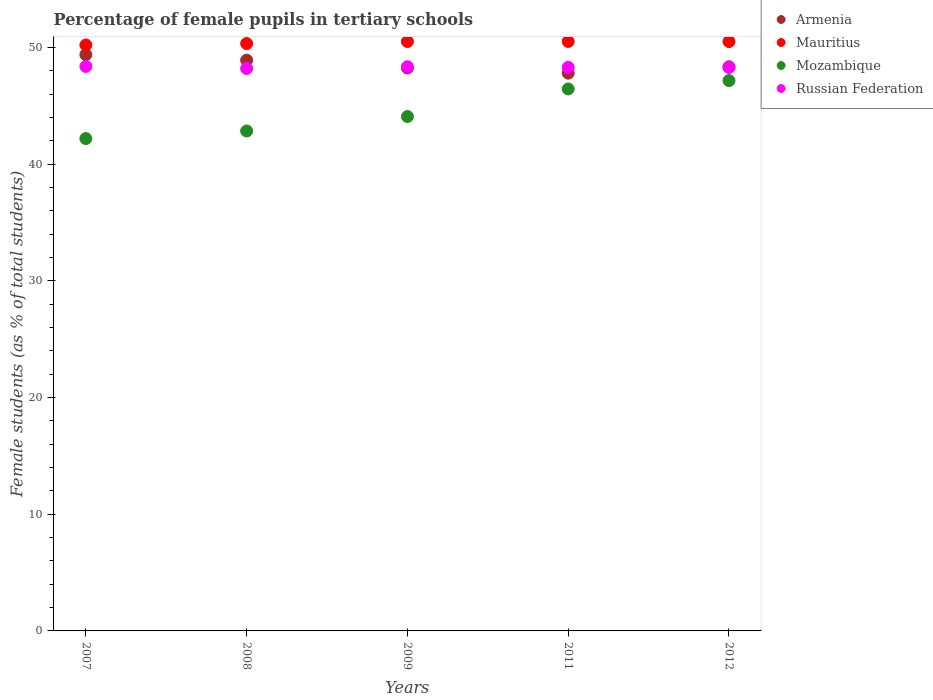Is the number of dotlines equal to the number of legend labels?
Keep it short and to the point. Yes. What is the percentage of female pupils in tertiary schools in Russian Federation in 2009?
Offer a terse response. 48.34. Across all years, what is the maximum percentage of female pupils in tertiary schools in Mozambique?
Your answer should be very brief. 47.16. Across all years, what is the minimum percentage of female pupils in tertiary schools in Armenia?
Ensure brevity in your answer.  47.79. In which year was the percentage of female pupils in tertiary schools in Russian Federation maximum?
Provide a short and direct response. 2007. What is the total percentage of female pupils in tertiary schools in Armenia in the graph?
Your answer should be compact. 242.67. What is the difference between the percentage of female pupils in tertiary schools in Russian Federation in 2007 and that in 2009?
Provide a succinct answer. 0.03. What is the difference between the percentage of female pupils in tertiary schools in Mozambique in 2008 and the percentage of female pupils in tertiary schools in Russian Federation in 2009?
Offer a very short reply. -5.5. What is the average percentage of female pupils in tertiary schools in Armenia per year?
Make the answer very short. 48.53. In the year 2007, what is the difference between the percentage of female pupils in tertiary schools in Russian Federation and percentage of female pupils in tertiary schools in Mozambique?
Keep it short and to the point. 6.19. What is the ratio of the percentage of female pupils in tertiary schools in Russian Federation in 2008 to that in 2009?
Offer a very short reply. 1. What is the difference between the highest and the second highest percentage of female pupils in tertiary schools in Armenia?
Make the answer very short. 0.47. What is the difference between the highest and the lowest percentage of female pupils in tertiary schools in Russian Federation?
Your answer should be compact. 0.18. Is it the case that in every year, the sum of the percentage of female pupils in tertiary schools in Mauritius and percentage of female pupils in tertiary schools in Mozambique  is greater than the sum of percentage of female pupils in tertiary schools in Armenia and percentage of female pupils in tertiary schools in Russian Federation?
Your answer should be compact. Yes. Is it the case that in every year, the sum of the percentage of female pupils in tertiary schools in Mauritius and percentage of female pupils in tertiary schools in Mozambique  is greater than the percentage of female pupils in tertiary schools in Armenia?
Keep it short and to the point. Yes. Does the graph contain any zero values?
Ensure brevity in your answer.  No. Does the graph contain grids?
Keep it short and to the point. No. How are the legend labels stacked?
Provide a succinct answer. Vertical. What is the title of the graph?
Provide a succinct answer. Percentage of female pupils in tertiary schools. What is the label or title of the Y-axis?
Give a very brief answer. Female students (as % of total students). What is the Female students (as % of total students) of Armenia in 2007?
Offer a terse response. 49.38. What is the Female students (as % of total students) of Mauritius in 2007?
Make the answer very short. 50.21. What is the Female students (as % of total students) of Mozambique in 2007?
Offer a very short reply. 42.19. What is the Female students (as % of total students) in Russian Federation in 2007?
Provide a short and direct response. 48.38. What is the Female students (as % of total students) in Armenia in 2008?
Give a very brief answer. 48.91. What is the Female students (as % of total students) of Mauritius in 2008?
Make the answer very short. 50.33. What is the Female students (as % of total students) in Mozambique in 2008?
Offer a very short reply. 42.84. What is the Female students (as % of total students) in Russian Federation in 2008?
Offer a terse response. 48.2. What is the Female students (as % of total students) of Armenia in 2009?
Your response must be concise. 48.24. What is the Female students (as % of total students) in Mauritius in 2009?
Your answer should be very brief. 50.51. What is the Female students (as % of total students) of Mozambique in 2009?
Keep it short and to the point. 44.08. What is the Female students (as % of total students) in Russian Federation in 2009?
Make the answer very short. 48.34. What is the Female students (as % of total students) of Armenia in 2011?
Your response must be concise. 47.79. What is the Female students (as % of total students) in Mauritius in 2011?
Your answer should be very brief. 50.51. What is the Female students (as % of total students) of Mozambique in 2011?
Your response must be concise. 46.44. What is the Female students (as % of total students) of Russian Federation in 2011?
Keep it short and to the point. 48.29. What is the Female students (as % of total students) in Armenia in 2012?
Make the answer very short. 48.34. What is the Female students (as % of total students) of Mauritius in 2012?
Your answer should be compact. 50.51. What is the Female students (as % of total students) in Mozambique in 2012?
Ensure brevity in your answer.  47.16. What is the Female students (as % of total students) of Russian Federation in 2012?
Provide a succinct answer. 48.29. Across all years, what is the maximum Female students (as % of total students) in Armenia?
Offer a very short reply. 49.38. Across all years, what is the maximum Female students (as % of total students) in Mauritius?
Offer a very short reply. 50.51. Across all years, what is the maximum Female students (as % of total students) of Mozambique?
Offer a very short reply. 47.16. Across all years, what is the maximum Female students (as % of total students) of Russian Federation?
Keep it short and to the point. 48.38. Across all years, what is the minimum Female students (as % of total students) in Armenia?
Your answer should be very brief. 47.79. Across all years, what is the minimum Female students (as % of total students) in Mauritius?
Provide a succinct answer. 50.21. Across all years, what is the minimum Female students (as % of total students) in Mozambique?
Your answer should be very brief. 42.19. Across all years, what is the minimum Female students (as % of total students) of Russian Federation?
Give a very brief answer. 48.2. What is the total Female students (as % of total students) of Armenia in the graph?
Keep it short and to the point. 242.67. What is the total Female students (as % of total students) in Mauritius in the graph?
Offer a terse response. 252.07. What is the total Female students (as % of total students) in Mozambique in the graph?
Your answer should be very brief. 222.71. What is the total Female students (as % of total students) in Russian Federation in the graph?
Provide a succinct answer. 241.49. What is the difference between the Female students (as % of total students) of Armenia in 2007 and that in 2008?
Offer a terse response. 0.47. What is the difference between the Female students (as % of total students) of Mauritius in 2007 and that in 2008?
Your response must be concise. -0.12. What is the difference between the Female students (as % of total students) of Mozambique in 2007 and that in 2008?
Your answer should be very brief. -0.65. What is the difference between the Female students (as % of total students) of Russian Federation in 2007 and that in 2008?
Ensure brevity in your answer.  0.18. What is the difference between the Female students (as % of total students) in Armenia in 2007 and that in 2009?
Offer a terse response. 1.14. What is the difference between the Female students (as % of total students) of Mauritius in 2007 and that in 2009?
Your answer should be compact. -0.3. What is the difference between the Female students (as % of total students) in Mozambique in 2007 and that in 2009?
Your answer should be very brief. -1.89. What is the difference between the Female students (as % of total students) in Russian Federation in 2007 and that in 2009?
Your answer should be very brief. 0.03. What is the difference between the Female students (as % of total students) of Armenia in 2007 and that in 2011?
Your answer should be very brief. 1.59. What is the difference between the Female students (as % of total students) of Mauritius in 2007 and that in 2011?
Your response must be concise. -0.3. What is the difference between the Female students (as % of total students) in Mozambique in 2007 and that in 2011?
Provide a short and direct response. -4.25. What is the difference between the Female students (as % of total students) of Russian Federation in 2007 and that in 2011?
Give a very brief answer. 0.09. What is the difference between the Female students (as % of total students) in Armenia in 2007 and that in 2012?
Offer a very short reply. 1.04. What is the difference between the Female students (as % of total students) of Mauritius in 2007 and that in 2012?
Ensure brevity in your answer.  -0.3. What is the difference between the Female students (as % of total students) of Mozambique in 2007 and that in 2012?
Offer a terse response. -4.97. What is the difference between the Female students (as % of total students) in Russian Federation in 2007 and that in 2012?
Offer a very short reply. 0.09. What is the difference between the Female students (as % of total students) in Armenia in 2008 and that in 2009?
Offer a terse response. 0.67. What is the difference between the Female students (as % of total students) of Mauritius in 2008 and that in 2009?
Your response must be concise. -0.17. What is the difference between the Female students (as % of total students) in Mozambique in 2008 and that in 2009?
Offer a very short reply. -1.24. What is the difference between the Female students (as % of total students) in Russian Federation in 2008 and that in 2009?
Offer a very short reply. -0.14. What is the difference between the Female students (as % of total students) in Armenia in 2008 and that in 2011?
Make the answer very short. 1.12. What is the difference between the Female students (as % of total students) in Mauritius in 2008 and that in 2011?
Provide a short and direct response. -0.18. What is the difference between the Female students (as % of total students) in Mozambique in 2008 and that in 2011?
Make the answer very short. -3.6. What is the difference between the Female students (as % of total students) in Russian Federation in 2008 and that in 2011?
Give a very brief answer. -0.09. What is the difference between the Female students (as % of total students) of Armenia in 2008 and that in 2012?
Your answer should be compact. 0.57. What is the difference between the Female students (as % of total students) in Mauritius in 2008 and that in 2012?
Keep it short and to the point. -0.17. What is the difference between the Female students (as % of total students) in Mozambique in 2008 and that in 2012?
Provide a succinct answer. -4.32. What is the difference between the Female students (as % of total students) of Russian Federation in 2008 and that in 2012?
Offer a terse response. -0.09. What is the difference between the Female students (as % of total students) of Armenia in 2009 and that in 2011?
Your answer should be very brief. 0.45. What is the difference between the Female students (as % of total students) of Mauritius in 2009 and that in 2011?
Provide a succinct answer. -0.01. What is the difference between the Female students (as % of total students) of Mozambique in 2009 and that in 2011?
Provide a short and direct response. -2.36. What is the difference between the Female students (as % of total students) of Russian Federation in 2009 and that in 2011?
Keep it short and to the point. 0.05. What is the difference between the Female students (as % of total students) of Armenia in 2009 and that in 2012?
Keep it short and to the point. -0.1. What is the difference between the Female students (as % of total students) in Mozambique in 2009 and that in 2012?
Your answer should be compact. -3.08. What is the difference between the Female students (as % of total students) of Russian Federation in 2009 and that in 2012?
Make the answer very short. 0.06. What is the difference between the Female students (as % of total students) of Armenia in 2011 and that in 2012?
Ensure brevity in your answer.  -0.54. What is the difference between the Female students (as % of total students) in Mauritius in 2011 and that in 2012?
Your answer should be very brief. 0.01. What is the difference between the Female students (as % of total students) of Mozambique in 2011 and that in 2012?
Offer a terse response. -0.72. What is the difference between the Female students (as % of total students) in Russian Federation in 2011 and that in 2012?
Provide a short and direct response. 0. What is the difference between the Female students (as % of total students) in Armenia in 2007 and the Female students (as % of total students) in Mauritius in 2008?
Your answer should be compact. -0.95. What is the difference between the Female students (as % of total students) of Armenia in 2007 and the Female students (as % of total students) of Mozambique in 2008?
Offer a terse response. 6.54. What is the difference between the Female students (as % of total students) in Armenia in 2007 and the Female students (as % of total students) in Russian Federation in 2008?
Your answer should be very brief. 1.18. What is the difference between the Female students (as % of total students) in Mauritius in 2007 and the Female students (as % of total students) in Mozambique in 2008?
Offer a very short reply. 7.37. What is the difference between the Female students (as % of total students) of Mauritius in 2007 and the Female students (as % of total students) of Russian Federation in 2008?
Your answer should be compact. 2.01. What is the difference between the Female students (as % of total students) of Mozambique in 2007 and the Female students (as % of total students) of Russian Federation in 2008?
Your response must be concise. -6.01. What is the difference between the Female students (as % of total students) in Armenia in 2007 and the Female students (as % of total students) in Mauritius in 2009?
Provide a succinct answer. -1.13. What is the difference between the Female students (as % of total students) in Armenia in 2007 and the Female students (as % of total students) in Mozambique in 2009?
Offer a terse response. 5.3. What is the difference between the Female students (as % of total students) in Armenia in 2007 and the Female students (as % of total students) in Russian Federation in 2009?
Give a very brief answer. 1.04. What is the difference between the Female students (as % of total students) of Mauritius in 2007 and the Female students (as % of total students) of Mozambique in 2009?
Your answer should be compact. 6.13. What is the difference between the Female students (as % of total students) of Mauritius in 2007 and the Female students (as % of total students) of Russian Federation in 2009?
Make the answer very short. 1.87. What is the difference between the Female students (as % of total students) in Mozambique in 2007 and the Female students (as % of total students) in Russian Federation in 2009?
Keep it short and to the point. -6.15. What is the difference between the Female students (as % of total students) in Armenia in 2007 and the Female students (as % of total students) in Mauritius in 2011?
Keep it short and to the point. -1.13. What is the difference between the Female students (as % of total students) of Armenia in 2007 and the Female students (as % of total students) of Mozambique in 2011?
Ensure brevity in your answer.  2.94. What is the difference between the Female students (as % of total students) of Armenia in 2007 and the Female students (as % of total students) of Russian Federation in 2011?
Give a very brief answer. 1.09. What is the difference between the Female students (as % of total students) in Mauritius in 2007 and the Female students (as % of total students) in Mozambique in 2011?
Give a very brief answer. 3.77. What is the difference between the Female students (as % of total students) of Mauritius in 2007 and the Female students (as % of total students) of Russian Federation in 2011?
Keep it short and to the point. 1.92. What is the difference between the Female students (as % of total students) of Armenia in 2007 and the Female students (as % of total students) of Mauritius in 2012?
Keep it short and to the point. -1.13. What is the difference between the Female students (as % of total students) in Armenia in 2007 and the Female students (as % of total students) in Mozambique in 2012?
Offer a very short reply. 2.22. What is the difference between the Female students (as % of total students) in Armenia in 2007 and the Female students (as % of total students) in Russian Federation in 2012?
Offer a very short reply. 1.1. What is the difference between the Female students (as % of total students) of Mauritius in 2007 and the Female students (as % of total students) of Mozambique in 2012?
Provide a succinct answer. 3.05. What is the difference between the Female students (as % of total students) in Mauritius in 2007 and the Female students (as % of total students) in Russian Federation in 2012?
Provide a succinct answer. 1.92. What is the difference between the Female students (as % of total students) of Mozambique in 2007 and the Female students (as % of total students) of Russian Federation in 2012?
Your response must be concise. -6.1. What is the difference between the Female students (as % of total students) in Armenia in 2008 and the Female students (as % of total students) in Mauritius in 2009?
Your response must be concise. -1.59. What is the difference between the Female students (as % of total students) of Armenia in 2008 and the Female students (as % of total students) of Mozambique in 2009?
Provide a succinct answer. 4.83. What is the difference between the Female students (as % of total students) in Armenia in 2008 and the Female students (as % of total students) in Russian Federation in 2009?
Your response must be concise. 0.57. What is the difference between the Female students (as % of total students) in Mauritius in 2008 and the Female students (as % of total students) in Mozambique in 2009?
Ensure brevity in your answer.  6.25. What is the difference between the Female students (as % of total students) of Mauritius in 2008 and the Female students (as % of total students) of Russian Federation in 2009?
Offer a terse response. 1.99. What is the difference between the Female students (as % of total students) in Mozambique in 2008 and the Female students (as % of total students) in Russian Federation in 2009?
Offer a terse response. -5.5. What is the difference between the Female students (as % of total students) of Armenia in 2008 and the Female students (as % of total students) of Mauritius in 2011?
Your response must be concise. -1.6. What is the difference between the Female students (as % of total students) of Armenia in 2008 and the Female students (as % of total students) of Mozambique in 2011?
Give a very brief answer. 2.47. What is the difference between the Female students (as % of total students) of Armenia in 2008 and the Female students (as % of total students) of Russian Federation in 2011?
Provide a short and direct response. 0.62. What is the difference between the Female students (as % of total students) of Mauritius in 2008 and the Female students (as % of total students) of Mozambique in 2011?
Your response must be concise. 3.89. What is the difference between the Female students (as % of total students) of Mauritius in 2008 and the Female students (as % of total students) of Russian Federation in 2011?
Ensure brevity in your answer.  2.04. What is the difference between the Female students (as % of total students) in Mozambique in 2008 and the Female students (as % of total students) in Russian Federation in 2011?
Offer a very short reply. -5.45. What is the difference between the Female students (as % of total students) of Armenia in 2008 and the Female students (as % of total students) of Mauritius in 2012?
Make the answer very short. -1.59. What is the difference between the Female students (as % of total students) of Armenia in 2008 and the Female students (as % of total students) of Mozambique in 2012?
Keep it short and to the point. 1.75. What is the difference between the Female students (as % of total students) in Armenia in 2008 and the Female students (as % of total students) in Russian Federation in 2012?
Keep it short and to the point. 0.63. What is the difference between the Female students (as % of total students) in Mauritius in 2008 and the Female students (as % of total students) in Mozambique in 2012?
Your response must be concise. 3.17. What is the difference between the Female students (as % of total students) in Mauritius in 2008 and the Female students (as % of total students) in Russian Federation in 2012?
Offer a very short reply. 2.05. What is the difference between the Female students (as % of total students) in Mozambique in 2008 and the Female students (as % of total students) in Russian Federation in 2012?
Provide a succinct answer. -5.45. What is the difference between the Female students (as % of total students) in Armenia in 2009 and the Female students (as % of total students) in Mauritius in 2011?
Your response must be concise. -2.27. What is the difference between the Female students (as % of total students) of Armenia in 2009 and the Female students (as % of total students) of Mozambique in 2011?
Provide a short and direct response. 1.8. What is the difference between the Female students (as % of total students) of Armenia in 2009 and the Female students (as % of total students) of Russian Federation in 2011?
Provide a short and direct response. -0.05. What is the difference between the Female students (as % of total students) in Mauritius in 2009 and the Female students (as % of total students) in Mozambique in 2011?
Your answer should be very brief. 4.06. What is the difference between the Female students (as % of total students) in Mauritius in 2009 and the Female students (as % of total students) in Russian Federation in 2011?
Ensure brevity in your answer.  2.22. What is the difference between the Female students (as % of total students) in Mozambique in 2009 and the Female students (as % of total students) in Russian Federation in 2011?
Ensure brevity in your answer.  -4.21. What is the difference between the Female students (as % of total students) of Armenia in 2009 and the Female students (as % of total students) of Mauritius in 2012?
Provide a succinct answer. -2.26. What is the difference between the Female students (as % of total students) of Armenia in 2009 and the Female students (as % of total students) of Mozambique in 2012?
Keep it short and to the point. 1.08. What is the difference between the Female students (as % of total students) of Armenia in 2009 and the Female students (as % of total students) of Russian Federation in 2012?
Provide a short and direct response. -0.04. What is the difference between the Female students (as % of total students) in Mauritius in 2009 and the Female students (as % of total students) in Mozambique in 2012?
Offer a very short reply. 3.35. What is the difference between the Female students (as % of total students) of Mauritius in 2009 and the Female students (as % of total students) of Russian Federation in 2012?
Offer a terse response. 2.22. What is the difference between the Female students (as % of total students) of Mozambique in 2009 and the Female students (as % of total students) of Russian Federation in 2012?
Offer a terse response. -4.21. What is the difference between the Female students (as % of total students) in Armenia in 2011 and the Female students (as % of total students) in Mauritius in 2012?
Your answer should be compact. -2.71. What is the difference between the Female students (as % of total students) of Armenia in 2011 and the Female students (as % of total students) of Mozambique in 2012?
Your answer should be compact. 0.63. What is the difference between the Female students (as % of total students) in Armenia in 2011 and the Female students (as % of total students) in Russian Federation in 2012?
Provide a short and direct response. -0.49. What is the difference between the Female students (as % of total students) in Mauritius in 2011 and the Female students (as % of total students) in Mozambique in 2012?
Give a very brief answer. 3.35. What is the difference between the Female students (as % of total students) of Mauritius in 2011 and the Female students (as % of total students) of Russian Federation in 2012?
Your response must be concise. 2.23. What is the difference between the Female students (as % of total students) in Mozambique in 2011 and the Female students (as % of total students) in Russian Federation in 2012?
Ensure brevity in your answer.  -1.84. What is the average Female students (as % of total students) of Armenia per year?
Offer a terse response. 48.53. What is the average Female students (as % of total students) of Mauritius per year?
Give a very brief answer. 50.41. What is the average Female students (as % of total students) of Mozambique per year?
Your answer should be compact. 44.54. What is the average Female students (as % of total students) in Russian Federation per year?
Make the answer very short. 48.3. In the year 2007, what is the difference between the Female students (as % of total students) in Armenia and Female students (as % of total students) in Mauritius?
Your answer should be very brief. -0.83. In the year 2007, what is the difference between the Female students (as % of total students) in Armenia and Female students (as % of total students) in Mozambique?
Offer a very short reply. 7.19. In the year 2007, what is the difference between the Female students (as % of total students) in Armenia and Female students (as % of total students) in Russian Federation?
Your response must be concise. 1.01. In the year 2007, what is the difference between the Female students (as % of total students) of Mauritius and Female students (as % of total students) of Mozambique?
Provide a short and direct response. 8.02. In the year 2007, what is the difference between the Female students (as % of total students) in Mauritius and Female students (as % of total students) in Russian Federation?
Offer a very short reply. 1.84. In the year 2007, what is the difference between the Female students (as % of total students) in Mozambique and Female students (as % of total students) in Russian Federation?
Ensure brevity in your answer.  -6.19. In the year 2008, what is the difference between the Female students (as % of total students) of Armenia and Female students (as % of total students) of Mauritius?
Provide a succinct answer. -1.42. In the year 2008, what is the difference between the Female students (as % of total students) of Armenia and Female students (as % of total students) of Mozambique?
Offer a very short reply. 6.07. In the year 2008, what is the difference between the Female students (as % of total students) of Armenia and Female students (as % of total students) of Russian Federation?
Make the answer very short. 0.71. In the year 2008, what is the difference between the Female students (as % of total students) in Mauritius and Female students (as % of total students) in Mozambique?
Your answer should be compact. 7.49. In the year 2008, what is the difference between the Female students (as % of total students) in Mauritius and Female students (as % of total students) in Russian Federation?
Your answer should be compact. 2.13. In the year 2008, what is the difference between the Female students (as % of total students) in Mozambique and Female students (as % of total students) in Russian Federation?
Provide a short and direct response. -5.36. In the year 2009, what is the difference between the Female students (as % of total students) in Armenia and Female students (as % of total students) in Mauritius?
Offer a terse response. -2.26. In the year 2009, what is the difference between the Female students (as % of total students) of Armenia and Female students (as % of total students) of Mozambique?
Give a very brief answer. 4.16. In the year 2009, what is the difference between the Female students (as % of total students) in Armenia and Female students (as % of total students) in Russian Federation?
Offer a very short reply. -0.1. In the year 2009, what is the difference between the Female students (as % of total students) of Mauritius and Female students (as % of total students) of Mozambique?
Offer a very short reply. 6.43. In the year 2009, what is the difference between the Female students (as % of total students) of Mauritius and Female students (as % of total students) of Russian Federation?
Provide a short and direct response. 2.16. In the year 2009, what is the difference between the Female students (as % of total students) in Mozambique and Female students (as % of total students) in Russian Federation?
Provide a succinct answer. -4.26. In the year 2011, what is the difference between the Female students (as % of total students) of Armenia and Female students (as % of total students) of Mauritius?
Provide a short and direct response. -2.72. In the year 2011, what is the difference between the Female students (as % of total students) in Armenia and Female students (as % of total students) in Mozambique?
Your answer should be compact. 1.35. In the year 2011, what is the difference between the Female students (as % of total students) in Armenia and Female students (as % of total students) in Russian Federation?
Offer a very short reply. -0.49. In the year 2011, what is the difference between the Female students (as % of total students) of Mauritius and Female students (as % of total students) of Mozambique?
Offer a terse response. 4.07. In the year 2011, what is the difference between the Female students (as % of total students) of Mauritius and Female students (as % of total students) of Russian Federation?
Make the answer very short. 2.23. In the year 2011, what is the difference between the Female students (as % of total students) in Mozambique and Female students (as % of total students) in Russian Federation?
Make the answer very short. -1.85. In the year 2012, what is the difference between the Female students (as % of total students) in Armenia and Female students (as % of total students) in Mauritius?
Give a very brief answer. -2.17. In the year 2012, what is the difference between the Female students (as % of total students) in Armenia and Female students (as % of total students) in Mozambique?
Your answer should be compact. 1.18. In the year 2012, what is the difference between the Female students (as % of total students) of Armenia and Female students (as % of total students) of Russian Federation?
Ensure brevity in your answer.  0.05. In the year 2012, what is the difference between the Female students (as % of total students) in Mauritius and Female students (as % of total students) in Mozambique?
Provide a short and direct response. 3.35. In the year 2012, what is the difference between the Female students (as % of total students) of Mauritius and Female students (as % of total students) of Russian Federation?
Make the answer very short. 2.22. In the year 2012, what is the difference between the Female students (as % of total students) of Mozambique and Female students (as % of total students) of Russian Federation?
Keep it short and to the point. -1.12. What is the ratio of the Female students (as % of total students) in Armenia in 2007 to that in 2008?
Your answer should be compact. 1.01. What is the ratio of the Female students (as % of total students) in Mozambique in 2007 to that in 2008?
Provide a succinct answer. 0.98. What is the ratio of the Female students (as % of total students) of Russian Federation in 2007 to that in 2008?
Keep it short and to the point. 1. What is the ratio of the Female students (as % of total students) in Armenia in 2007 to that in 2009?
Ensure brevity in your answer.  1.02. What is the ratio of the Female students (as % of total students) in Mauritius in 2007 to that in 2009?
Make the answer very short. 0.99. What is the ratio of the Female students (as % of total students) in Mozambique in 2007 to that in 2009?
Give a very brief answer. 0.96. What is the ratio of the Female students (as % of total students) of Russian Federation in 2007 to that in 2009?
Make the answer very short. 1. What is the ratio of the Female students (as % of total students) of Armenia in 2007 to that in 2011?
Offer a very short reply. 1.03. What is the ratio of the Female students (as % of total students) in Mozambique in 2007 to that in 2011?
Your response must be concise. 0.91. What is the ratio of the Female students (as % of total students) in Armenia in 2007 to that in 2012?
Make the answer very short. 1.02. What is the ratio of the Female students (as % of total students) in Mauritius in 2007 to that in 2012?
Offer a very short reply. 0.99. What is the ratio of the Female students (as % of total students) in Mozambique in 2007 to that in 2012?
Your response must be concise. 0.89. What is the ratio of the Female students (as % of total students) in Armenia in 2008 to that in 2009?
Your answer should be very brief. 1.01. What is the ratio of the Female students (as % of total students) in Mozambique in 2008 to that in 2009?
Ensure brevity in your answer.  0.97. What is the ratio of the Female students (as % of total students) of Russian Federation in 2008 to that in 2009?
Provide a succinct answer. 1. What is the ratio of the Female students (as % of total students) of Armenia in 2008 to that in 2011?
Your answer should be compact. 1.02. What is the ratio of the Female students (as % of total students) in Mozambique in 2008 to that in 2011?
Give a very brief answer. 0.92. What is the ratio of the Female students (as % of total students) of Armenia in 2008 to that in 2012?
Ensure brevity in your answer.  1.01. What is the ratio of the Female students (as % of total students) of Mozambique in 2008 to that in 2012?
Offer a terse response. 0.91. What is the ratio of the Female students (as % of total students) of Russian Federation in 2008 to that in 2012?
Provide a short and direct response. 1. What is the ratio of the Female students (as % of total students) in Armenia in 2009 to that in 2011?
Your response must be concise. 1.01. What is the ratio of the Female students (as % of total students) of Mozambique in 2009 to that in 2011?
Give a very brief answer. 0.95. What is the ratio of the Female students (as % of total students) of Russian Federation in 2009 to that in 2011?
Your answer should be very brief. 1. What is the ratio of the Female students (as % of total students) in Mauritius in 2009 to that in 2012?
Offer a very short reply. 1. What is the ratio of the Female students (as % of total students) of Mozambique in 2009 to that in 2012?
Your answer should be very brief. 0.93. What is the ratio of the Female students (as % of total students) in Armenia in 2011 to that in 2012?
Offer a terse response. 0.99. What is the ratio of the Female students (as % of total students) of Mozambique in 2011 to that in 2012?
Offer a very short reply. 0.98. What is the ratio of the Female students (as % of total students) of Russian Federation in 2011 to that in 2012?
Your answer should be very brief. 1. What is the difference between the highest and the second highest Female students (as % of total students) in Armenia?
Ensure brevity in your answer.  0.47. What is the difference between the highest and the second highest Female students (as % of total students) in Mauritius?
Make the answer very short. 0.01. What is the difference between the highest and the second highest Female students (as % of total students) in Mozambique?
Your response must be concise. 0.72. What is the difference between the highest and the second highest Female students (as % of total students) of Russian Federation?
Provide a succinct answer. 0.03. What is the difference between the highest and the lowest Female students (as % of total students) in Armenia?
Provide a succinct answer. 1.59. What is the difference between the highest and the lowest Female students (as % of total students) in Mauritius?
Ensure brevity in your answer.  0.3. What is the difference between the highest and the lowest Female students (as % of total students) in Mozambique?
Offer a terse response. 4.97. What is the difference between the highest and the lowest Female students (as % of total students) of Russian Federation?
Offer a very short reply. 0.18. 